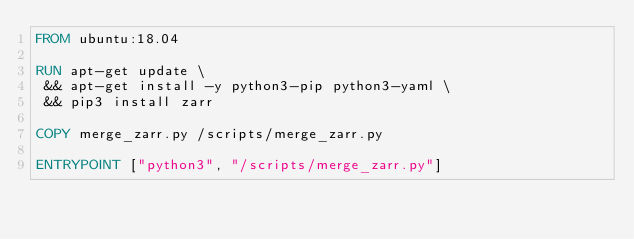<code> <loc_0><loc_0><loc_500><loc_500><_Dockerfile_>FROM ubuntu:18.04

RUN apt-get update \
 && apt-get install -y python3-pip python3-yaml \
 && pip3 install zarr

COPY merge_zarr.py /scripts/merge_zarr.py

ENTRYPOINT ["python3", "/scripts/merge_zarr.py"]
</code> 